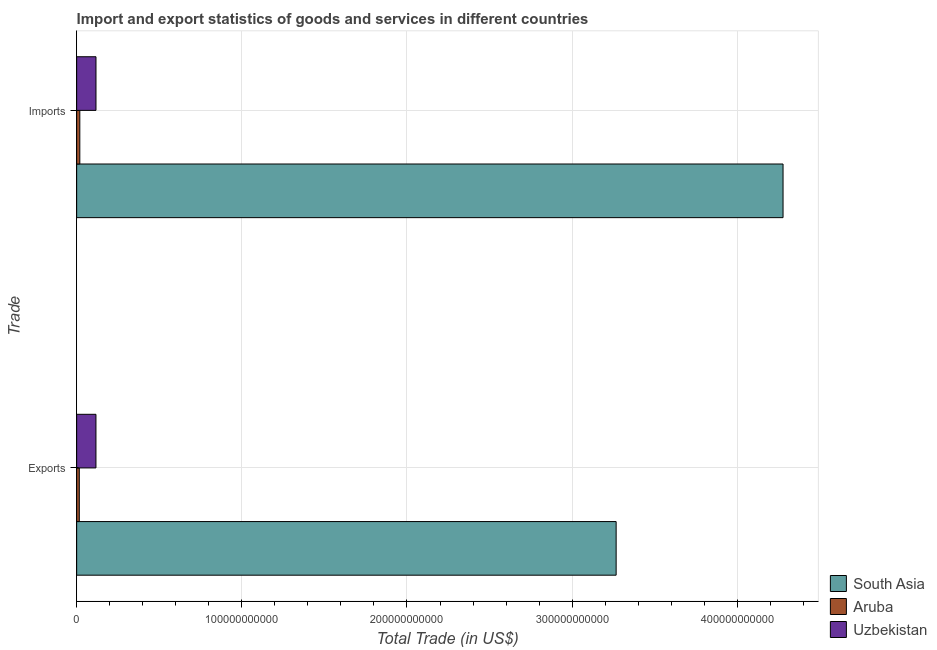Are the number of bars on each tick of the Y-axis equal?
Offer a very short reply. Yes. How many bars are there on the 1st tick from the top?
Make the answer very short. 3. What is the label of the 2nd group of bars from the top?
Your response must be concise. Exports. What is the imports of goods and services in South Asia?
Offer a terse response. 4.28e+11. Across all countries, what is the maximum export of goods and services?
Give a very brief answer. 3.27e+11. Across all countries, what is the minimum export of goods and services?
Make the answer very short. 1.59e+09. In which country was the imports of goods and services maximum?
Make the answer very short. South Asia. In which country was the imports of goods and services minimum?
Offer a terse response. Aruba. What is the total imports of goods and services in the graph?
Give a very brief answer. 4.41e+11. What is the difference between the imports of goods and services in Uzbekistan and that in Aruba?
Offer a very short reply. 9.79e+09. What is the difference between the export of goods and services in Aruba and the imports of goods and services in South Asia?
Ensure brevity in your answer.  -4.26e+11. What is the average export of goods and services per country?
Provide a short and direct response. 1.13e+11. What is the difference between the imports of goods and services and export of goods and services in Uzbekistan?
Provide a succinct answer. 1.86e+07. In how many countries, is the export of goods and services greater than 80000000000 US$?
Offer a terse response. 1. What is the ratio of the imports of goods and services in Aruba to that in South Asia?
Provide a succinct answer. 0. Is the imports of goods and services in Uzbekistan less than that in Aruba?
Offer a terse response. No. In how many countries, is the export of goods and services greater than the average export of goods and services taken over all countries?
Give a very brief answer. 1. What does the 1st bar from the top in Exports represents?
Offer a terse response. Uzbekistan. What does the 2nd bar from the bottom in Exports represents?
Your answer should be very brief. Aruba. What is the difference between two consecutive major ticks on the X-axis?
Provide a succinct answer. 1.00e+11. Does the graph contain any zero values?
Your response must be concise. No. How many legend labels are there?
Offer a very short reply. 3. What is the title of the graph?
Your response must be concise. Import and export statistics of goods and services in different countries. Does "Nepal" appear as one of the legend labels in the graph?
Provide a short and direct response. No. What is the label or title of the X-axis?
Offer a terse response. Total Trade (in US$). What is the label or title of the Y-axis?
Provide a succinct answer. Trade. What is the Total Trade (in US$) of South Asia in Exports?
Provide a short and direct response. 3.27e+11. What is the Total Trade (in US$) in Aruba in Exports?
Your answer should be compact. 1.59e+09. What is the Total Trade (in US$) in Uzbekistan in Exports?
Offer a very short reply. 1.17e+1. What is the Total Trade (in US$) of South Asia in Imports?
Your answer should be very brief. 4.28e+11. What is the Total Trade (in US$) in Aruba in Imports?
Your answer should be compact. 1.91e+09. What is the Total Trade (in US$) of Uzbekistan in Imports?
Ensure brevity in your answer.  1.17e+1. Across all Trade, what is the maximum Total Trade (in US$) in South Asia?
Your answer should be compact. 4.28e+11. Across all Trade, what is the maximum Total Trade (in US$) in Aruba?
Ensure brevity in your answer.  1.91e+09. Across all Trade, what is the maximum Total Trade (in US$) in Uzbekistan?
Provide a short and direct response. 1.17e+1. Across all Trade, what is the minimum Total Trade (in US$) in South Asia?
Keep it short and to the point. 3.27e+11. Across all Trade, what is the minimum Total Trade (in US$) of Aruba?
Your answer should be very brief. 1.59e+09. Across all Trade, what is the minimum Total Trade (in US$) in Uzbekistan?
Keep it short and to the point. 1.17e+1. What is the total Total Trade (in US$) in South Asia in the graph?
Provide a short and direct response. 7.54e+11. What is the total Total Trade (in US$) in Aruba in the graph?
Your answer should be very brief. 3.50e+09. What is the total Total Trade (in US$) in Uzbekistan in the graph?
Your answer should be very brief. 2.34e+1. What is the difference between the Total Trade (in US$) of South Asia in Exports and that in Imports?
Provide a short and direct response. -1.01e+11. What is the difference between the Total Trade (in US$) of Aruba in Exports and that in Imports?
Offer a terse response. -3.12e+08. What is the difference between the Total Trade (in US$) in Uzbekistan in Exports and that in Imports?
Provide a succinct answer. -1.86e+07. What is the difference between the Total Trade (in US$) of South Asia in Exports and the Total Trade (in US$) of Aruba in Imports?
Keep it short and to the point. 3.25e+11. What is the difference between the Total Trade (in US$) of South Asia in Exports and the Total Trade (in US$) of Uzbekistan in Imports?
Your answer should be compact. 3.15e+11. What is the difference between the Total Trade (in US$) in Aruba in Exports and the Total Trade (in US$) in Uzbekistan in Imports?
Give a very brief answer. -1.01e+1. What is the average Total Trade (in US$) in South Asia per Trade?
Your response must be concise. 3.77e+11. What is the average Total Trade (in US$) of Aruba per Trade?
Your answer should be compact. 1.75e+09. What is the average Total Trade (in US$) in Uzbekistan per Trade?
Your response must be concise. 1.17e+1. What is the difference between the Total Trade (in US$) in South Asia and Total Trade (in US$) in Aruba in Exports?
Your answer should be very brief. 3.25e+11. What is the difference between the Total Trade (in US$) of South Asia and Total Trade (in US$) of Uzbekistan in Exports?
Provide a succinct answer. 3.15e+11. What is the difference between the Total Trade (in US$) in Aruba and Total Trade (in US$) in Uzbekistan in Exports?
Offer a terse response. -1.01e+1. What is the difference between the Total Trade (in US$) in South Asia and Total Trade (in US$) in Aruba in Imports?
Provide a short and direct response. 4.26e+11. What is the difference between the Total Trade (in US$) in South Asia and Total Trade (in US$) in Uzbekistan in Imports?
Your response must be concise. 4.16e+11. What is the difference between the Total Trade (in US$) in Aruba and Total Trade (in US$) in Uzbekistan in Imports?
Offer a very short reply. -9.79e+09. What is the ratio of the Total Trade (in US$) in South Asia in Exports to that in Imports?
Give a very brief answer. 0.76. What is the ratio of the Total Trade (in US$) in Aruba in Exports to that in Imports?
Provide a short and direct response. 0.84. What is the ratio of the Total Trade (in US$) in Uzbekistan in Exports to that in Imports?
Offer a terse response. 1. What is the difference between the highest and the second highest Total Trade (in US$) of South Asia?
Your answer should be very brief. 1.01e+11. What is the difference between the highest and the second highest Total Trade (in US$) of Aruba?
Provide a succinct answer. 3.12e+08. What is the difference between the highest and the second highest Total Trade (in US$) in Uzbekistan?
Your answer should be very brief. 1.86e+07. What is the difference between the highest and the lowest Total Trade (in US$) in South Asia?
Give a very brief answer. 1.01e+11. What is the difference between the highest and the lowest Total Trade (in US$) of Aruba?
Your answer should be compact. 3.12e+08. What is the difference between the highest and the lowest Total Trade (in US$) of Uzbekistan?
Offer a terse response. 1.86e+07. 